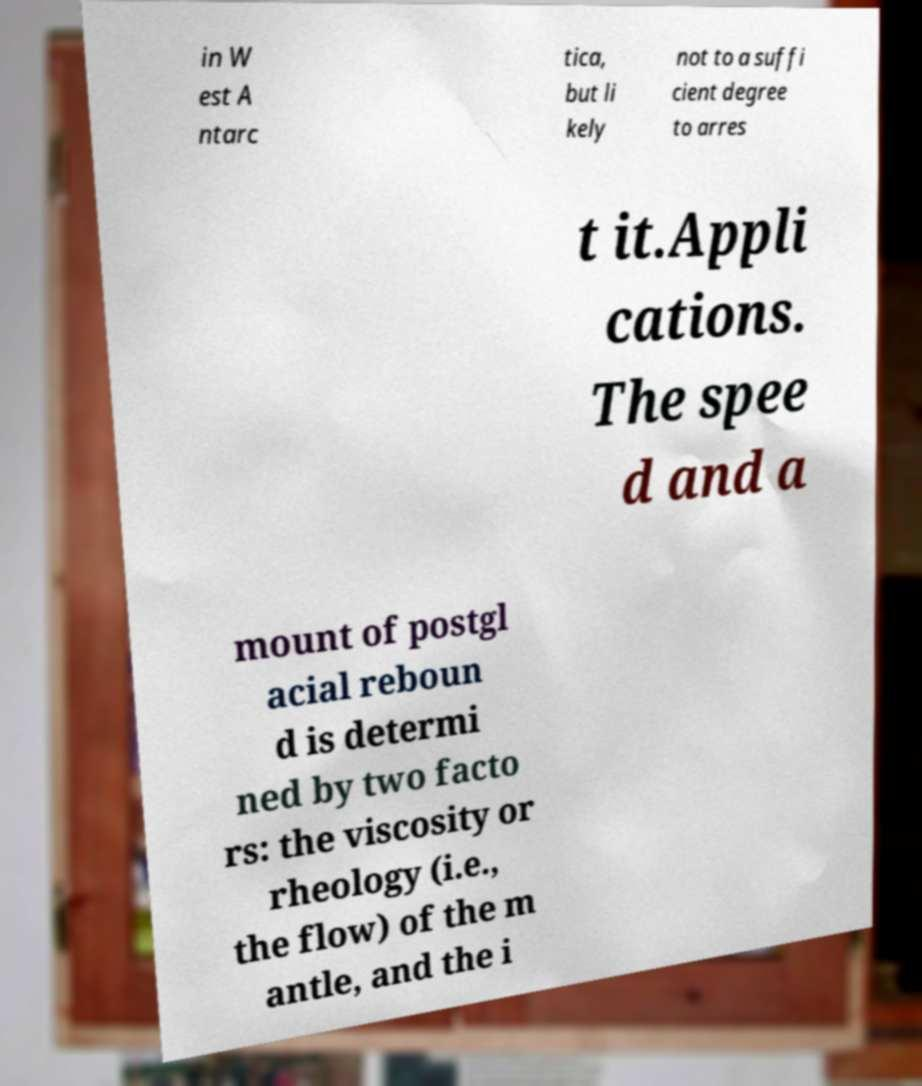Could you extract and type out the text from this image? in W est A ntarc tica, but li kely not to a suffi cient degree to arres t it.Appli cations. The spee d and a mount of postgl acial reboun d is determi ned by two facto rs: the viscosity or rheology (i.e., the flow) of the m antle, and the i 